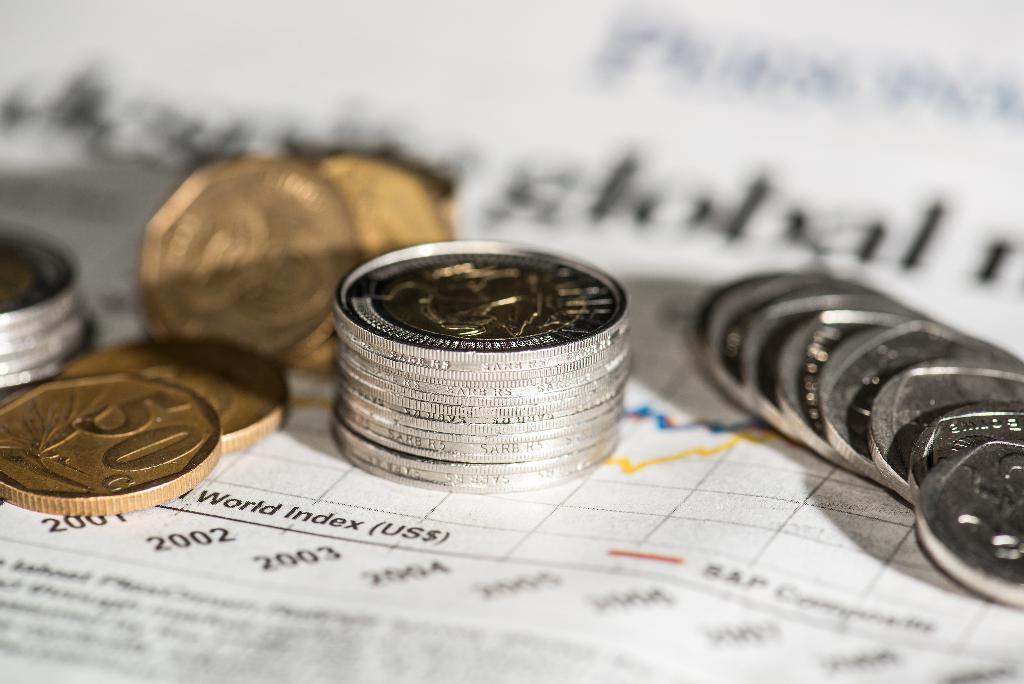What is the number on the copper coin to the left?
Offer a very short reply. 50. 